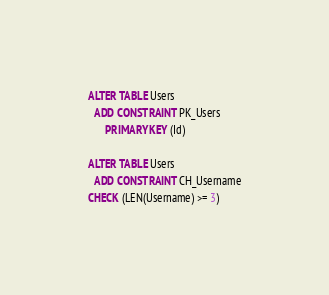Convert code to text. <code><loc_0><loc_0><loc_500><loc_500><_SQL_>ALTER TABLE Users
  ADD CONSTRAINT PK_Users
      PRIMARY KEY (Id)

ALTER TABLE Users
  ADD CONSTRAINT CH_Username
CHECK (LEN(Username) >= 3)</code> 